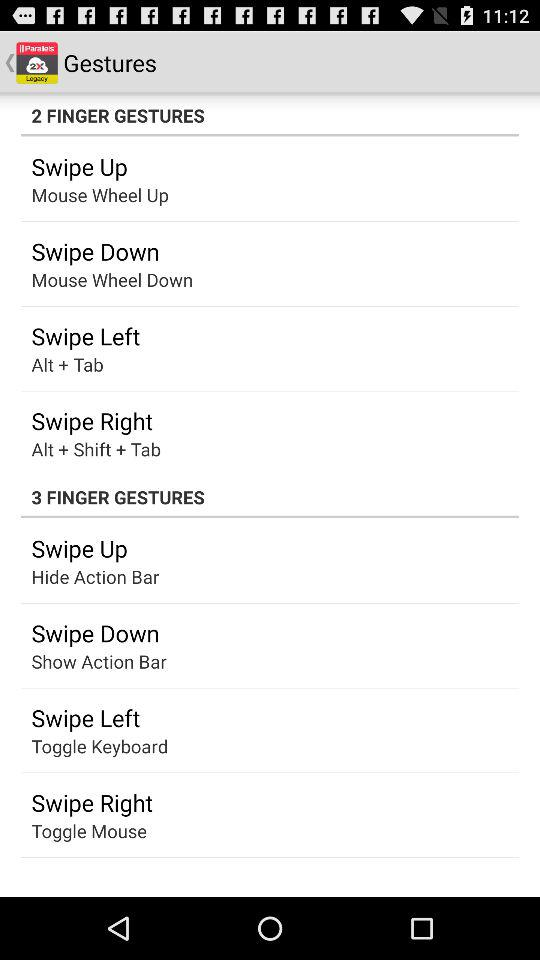How to swipe up in "2 FINGER GESTURES"? To swipe up in "2 FINGER GESTURES", scroll the mouse wheel up. 